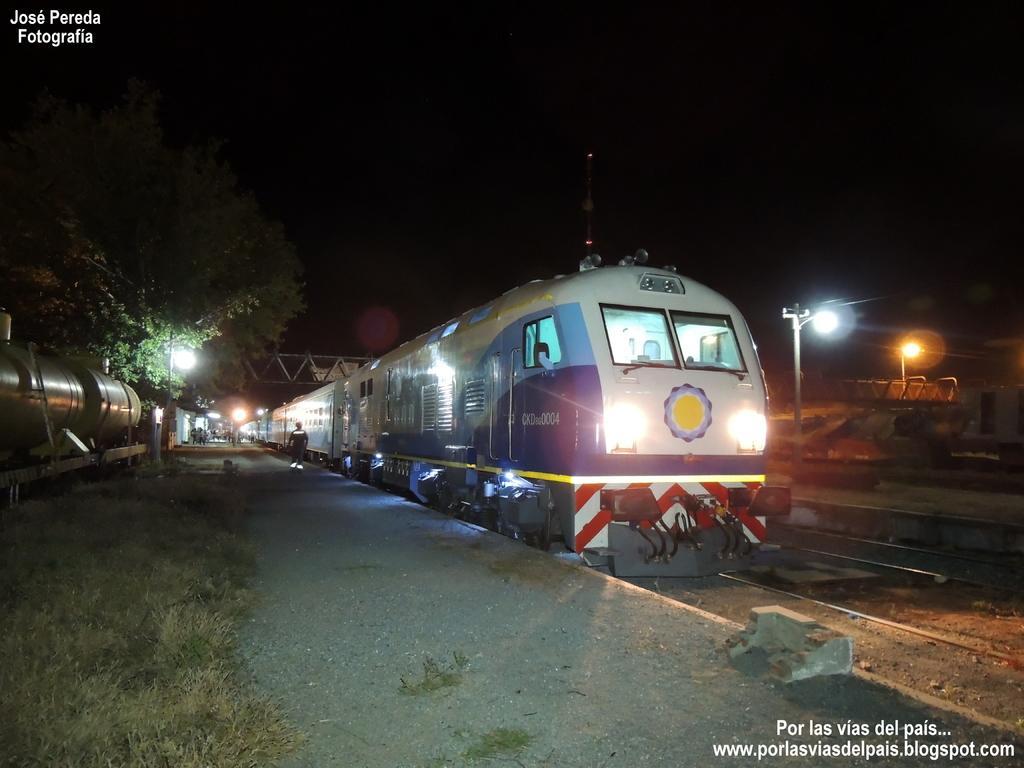Describe this image in one or two sentences. In this image, I see a train and track over here and a path side to it and there is a grass over here. In the background I see the tree, few lights and few people over here. 